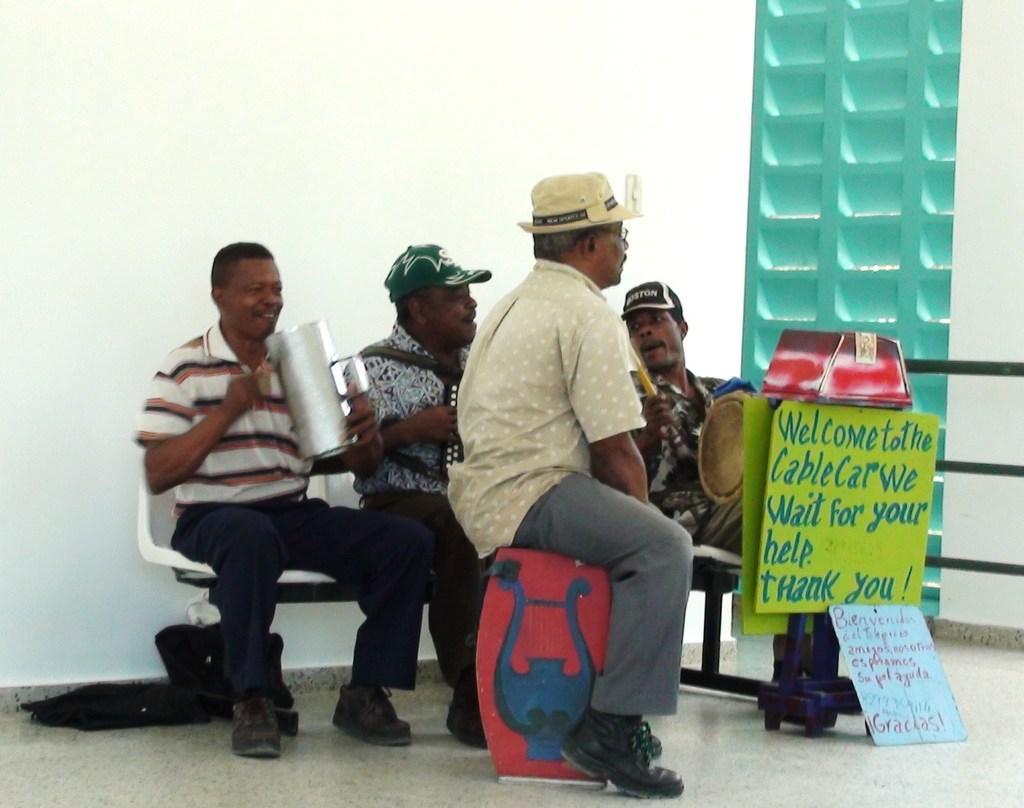Can you describe this image briefly? In this picture there are group of people those who are sitting in the center of the image and there is a cable car poster on the right side of the image. 